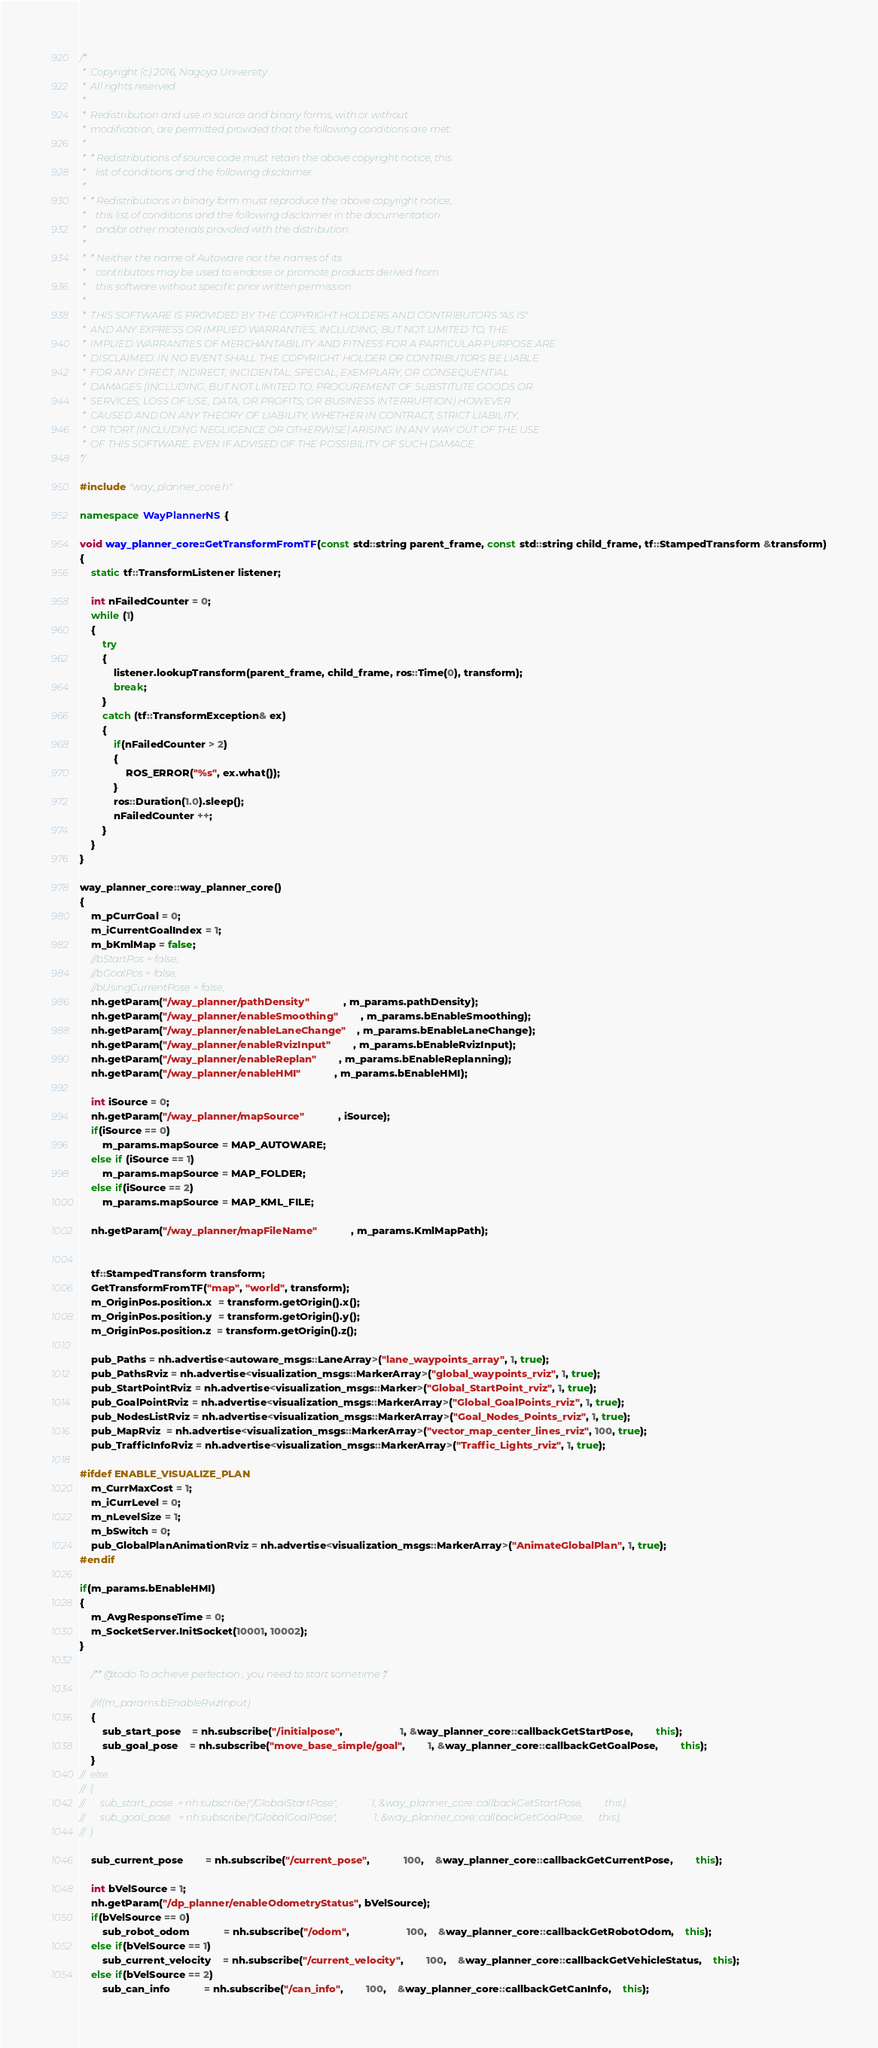Convert code to text. <code><loc_0><loc_0><loc_500><loc_500><_C++_>/*
 *  Copyright (c) 2016, Nagoya University
 *  All rights reserved.
 *
 *  Redistribution and use in source and binary forms, with or without
 *  modification, are permitted provided that the following conditions are met:
 *
 *  * Redistributions of source code must retain the above copyright notice, this
 *    list of conditions and the following disclaimer.
 *
 *  * Redistributions in binary form must reproduce the above copyright notice,
 *    this list of conditions and the following disclaimer in the documentation
 *    and/or other materials provided with the distribution.
 *
 *  * Neither the name of Autoware nor the names of its
 *    contributors may be used to endorse or promote products derived from
 *    this software without specific prior written permission.
 *
 *  THIS SOFTWARE IS PROVIDED BY THE COPYRIGHT HOLDERS AND CONTRIBUTORS "AS IS"
 *  AND ANY EXPRESS OR IMPLIED WARRANTIES, INCLUDING, BUT NOT LIMITED TO, THE
 *  IMPLIED WARRANTIES OF MERCHANTABILITY AND FITNESS FOR A PARTICULAR PURPOSE ARE
 *  DISCLAIMED. IN NO EVENT SHALL THE COPYRIGHT HOLDER OR CONTRIBUTORS BE LIABLE
 *  FOR ANY DIRECT, INDIRECT, INCIDENTAL, SPECIAL, EXEMPLARY, OR CONSEQUENTIAL
 *  DAMAGES (INCLUDING, BUT NOT LIMITED TO, PROCUREMENT OF SUBSTITUTE GOODS OR
 *  SERVICES; LOSS OF USE, DATA, OR PROFITS; OR BUSINESS INTERRUPTION) HOWEVER
 *  CAUSED AND ON ANY THEORY OF LIABILITY, WHETHER IN CONTRACT, STRICT LIABILITY,
 *  OR TORT (INCLUDING NEGLIGENCE OR OTHERWISE) ARISING IN ANY WAY OUT OF THE USE
 *  OF THIS SOFTWARE, EVEN IF ADVISED OF THE POSSIBILITY OF SUCH DAMAGE.
*/

#include "way_planner_core.h"

namespace WayPlannerNS {

void way_planner_core::GetTransformFromTF(const std::string parent_frame, const std::string child_frame, tf::StampedTransform &transform)
{
	static tf::TransformListener listener;

	int nFailedCounter = 0;
	while (1)
	{
		try
		{
			listener.lookupTransform(parent_frame, child_frame, ros::Time(0), transform);
			break;
		}
		catch (tf::TransformException& ex)
		{
			if(nFailedCounter > 2)
			{
				ROS_ERROR("%s", ex.what());
			}
			ros::Duration(1.0).sleep();
			nFailedCounter ++;
		}
	}
}

way_planner_core::way_planner_core()
{
	m_pCurrGoal = 0;
	m_iCurrentGoalIndex = 1;
	m_bKmlMap = false;
	//bStartPos = false;
	//bGoalPos = false;
	//bUsingCurrentPose = false;
	nh.getParam("/way_planner/pathDensity" 			, m_params.pathDensity);
	nh.getParam("/way_planner/enableSmoothing" 		, m_params.bEnableSmoothing);
	nh.getParam("/way_planner/enableLaneChange" 	, m_params.bEnableLaneChange);
	nh.getParam("/way_planner/enableRvizInput" 		, m_params.bEnableRvizInput);
	nh.getParam("/way_planner/enableReplan" 		, m_params.bEnableReplanning);
	nh.getParam("/way_planner/enableHMI" 			, m_params.bEnableHMI);

	int iSource = 0;
	nh.getParam("/way_planner/mapSource" 			, iSource);
	if(iSource == 0)
		m_params.mapSource = MAP_AUTOWARE;
	else if (iSource == 1)
		m_params.mapSource = MAP_FOLDER;
	else if(iSource == 2)
		m_params.mapSource = MAP_KML_FILE;

	nh.getParam("/way_planner/mapFileName" 			, m_params.KmlMapPath);


	tf::StampedTransform transform;
	GetTransformFromTF("map", "world", transform);
	m_OriginPos.position.x  = transform.getOrigin().x();
	m_OriginPos.position.y  = transform.getOrigin().y();
	m_OriginPos.position.z  = transform.getOrigin().z();

	pub_Paths = nh.advertise<autoware_msgs::LaneArray>("lane_waypoints_array", 1, true);
	pub_PathsRviz = nh.advertise<visualization_msgs::MarkerArray>("global_waypoints_rviz", 1, true);
	pub_StartPointRviz = nh.advertise<visualization_msgs::Marker>("Global_StartPoint_rviz", 1, true);
	pub_GoalPointRviz = nh.advertise<visualization_msgs::MarkerArray>("Global_GoalPoints_rviz", 1, true);
	pub_NodesListRviz = nh.advertise<visualization_msgs::MarkerArray>("Goal_Nodes_Points_rviz", 1, true);
	pub_MapRviz  = nh.advertise<visualization_msgs::MarkerArray>("vector_map_center_lines_rviz", 100, true);
	pub_TrafficInfoRviz = nh.advertise<visualization_msgs::MarkerArray>("Traffic_Lights_rviz", 1, true);

#ifdef ENABLE_VISUALIZE_PLAN
	m_CurrMaxCost = 1;
	m_iCurrLevel = 0;
	m_nLevelSize = 1;
	m_bSwitch = 0;
	pub_GlobalPlanAnimationRviz = nh.advertise<visualization_msgs::MarkerArray>("AnimateGlobalPlan", 1, true);
#endif

if(m_params.bEnableHMI)
{
	m_AvgResponseTime = 0;
	m_SocketServer.InitSocket(10001, 10002);
}

	/** @todo To achieve perfection , you need to start sometime */

	//if(m_params.bEnableRvizInput)
	{
		sub_start_pose 	= nh.subscribe("/initialpose", 					1, &way_planner_core::callbackGetStartPose, 		this);
		sub_goal_pose 	= nh.subscribe("move_base_simple/goal", 		1, &way_planner_core::callbackGetGoalPose, 		this);
	}
//	else
//	{
//		sub_start_pose 	= nh.subscribe("/GlobalStartPose", 				1, &way_planner_core::callbackGetStartPose, 		this);
//		sub_goal_pose 	= nh.subscribe("/GlobalGoalPose", 				1, &way_planner_core::callbackGetGoalPose, 		this);
//	}

	sub_current_pose 		= nh.subscribe("/current_pose", 			100,	&way_planner_core::callbackGetCurrentPose, 		this);

	int bVelSource = 1;
	nh.getParam("/dp_planner/enableOdometryStatus", bVelSource);
	if(bVelSource == 0)
		sub_robot_odom 			= nh.subscribe("/odom", 					100,	&way_planner_core::callbackGetRobotOdom, 	this);
	else if(bVelSource == 1)
		sub_current_velocity 	= nh.subscribe("/current_velocity",		100,	&way_planner_core::callbackGetVehicleStatus, 	this);
	else if(bVelSource == 2)
		sub_can_info 			= nh.subscribe("/can_info",		100,	&way_planner_core::callbackGetCanInfo, 	this);
</code> 